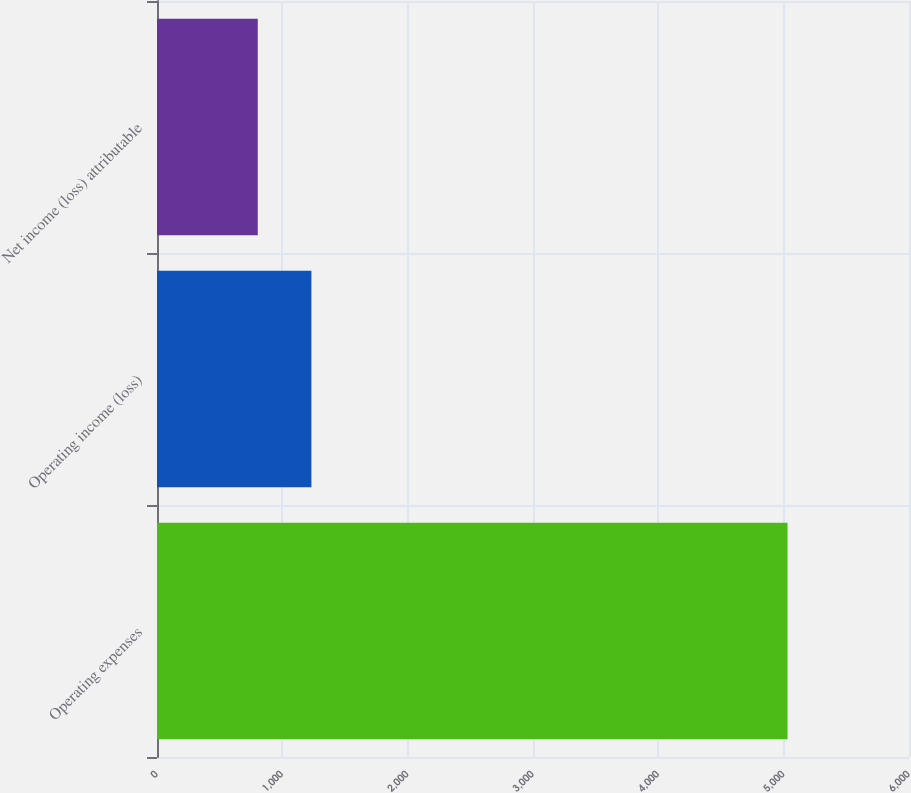Convert chart. <chart><loc_0><loc_0><loc_500><loc_500><bar_chart><fcel>Operating expenses<fcel>Operating income (loss)<fcel>Net income (loss) attributable<nl><fcel>5031<fcel>1232<fcel>804<nl></chart> 